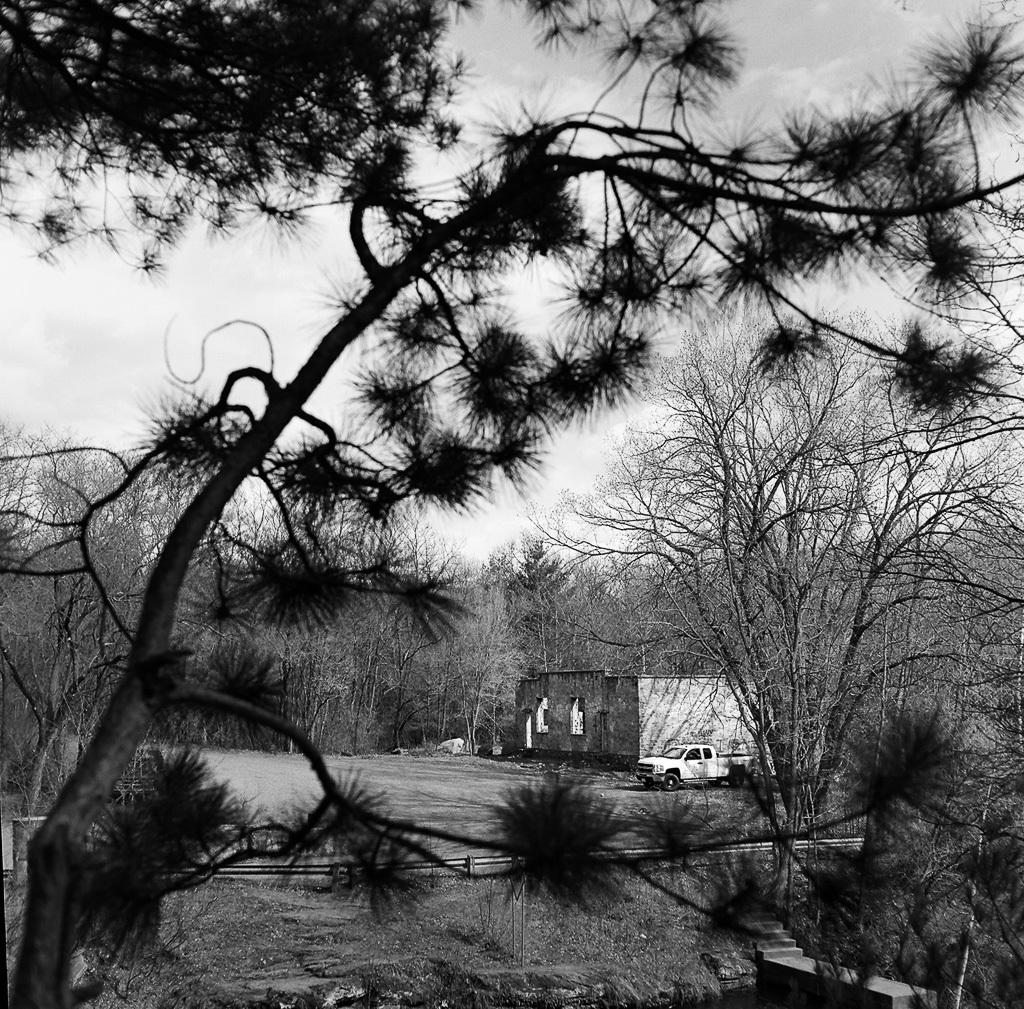What type of natural elements can be seen in the image? There are many trees in the image. What type of man-made structure is present in the image? There is a broken building in the image. What vehicle is located beside the building? There is a truck beside the building. What can be seen on the ground in front of the building? The ground is visible in front of the building. What is the condition of the sky in the image? The sky is clear in the image. What type of game is being played on the roof of the building in the image? There is no game being played on the roof of the building in the image, as there is no indication of any game or activity taking place on the roof. 